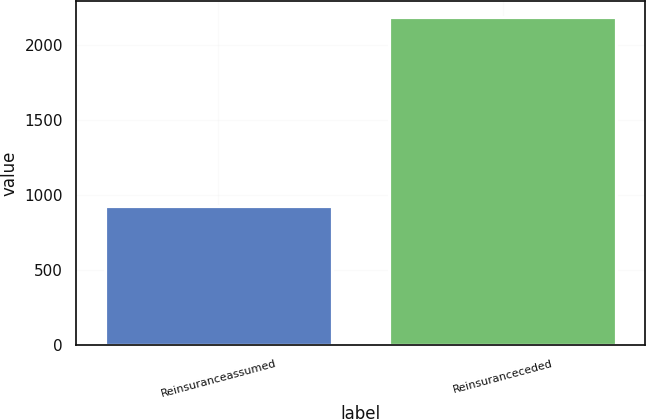Convert chart to OTSL. <chart><loc_0><loc_0><loc_500><loc_500><bar_chart><fcel>Reinsuranceassumed<fcel>Reinsuranceceded<nl><fcel>928<fcel>2184<nl></chart> 